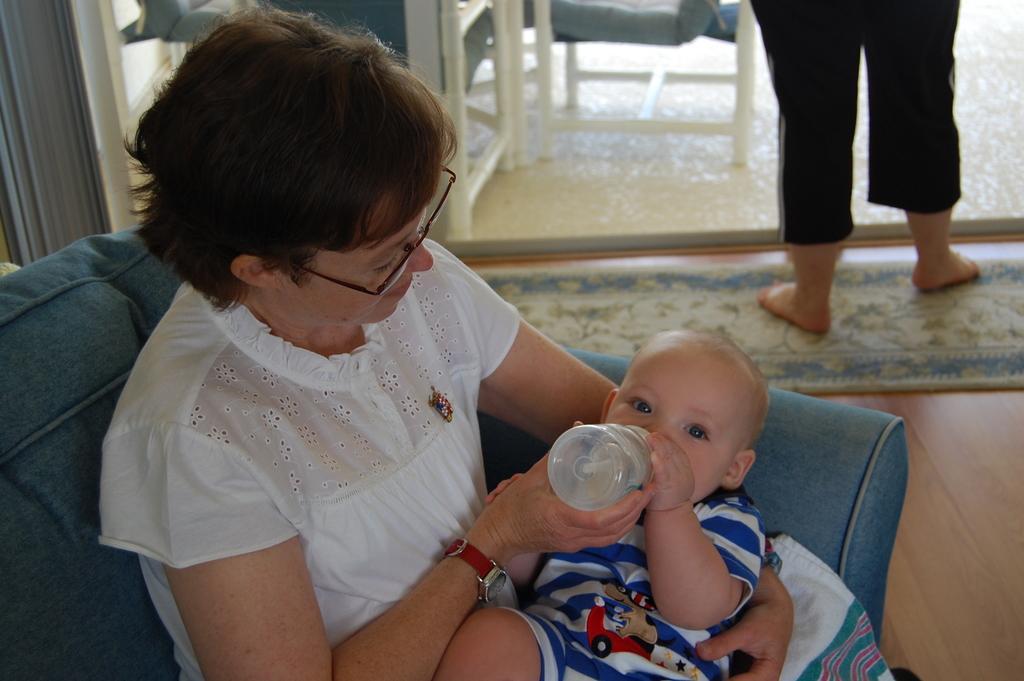Please provide a concise description of this image. This woman is sitting on a couch and carrying a baby. This baby is drinking a milk from this bottle. This person is standing. A floor with carpet. This person wore white dress and spectacles. 